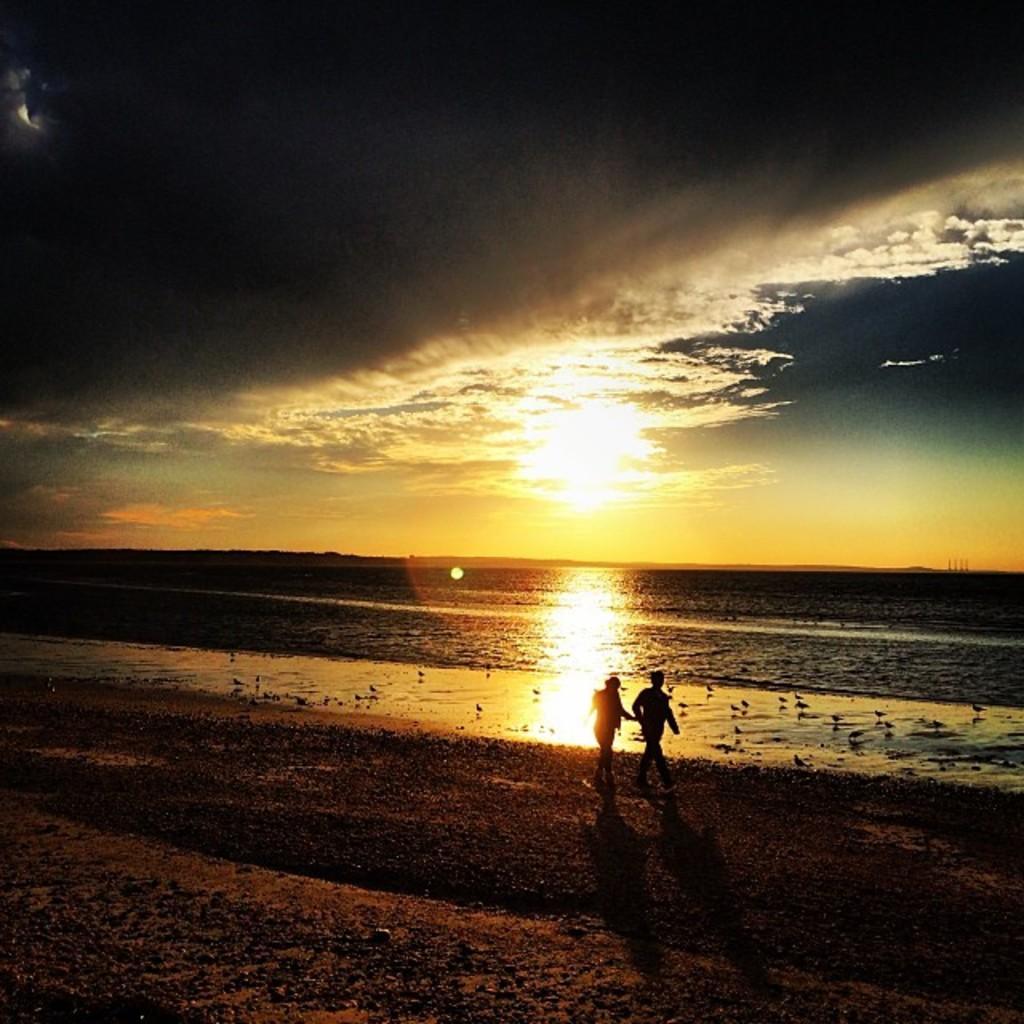How would you summarize this image in a sentence or two? There are two persons standing in the beach area as we can see at the bottom of this image. There is a Sea in the middle of this image, and there is a sky at the top of this image. 